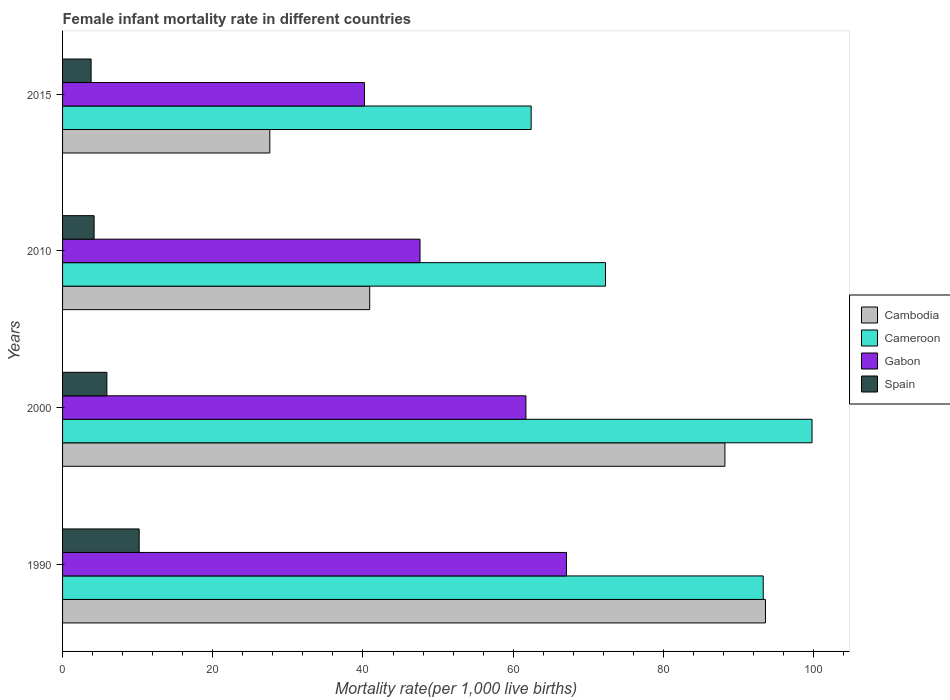How many groups of bars are there?
Your response must be concise. 4. How many bars are there on the 3rd tick from the bottom?
Offer a terse response. 4. What is the label of the 3rd group of bars from the top?
Your response must be concise. 2000. In how many cases, is the number of bars for a given year not equal to the number of legend labels?
Your answer should be very brief. 0. What is the female infant mortality rate in Spain in 2000?
Offer a terse response. 5.9. Across all years, what is the maximum female infant mortality rate in Cameroon?
Provide a short and direct response. 99.8. Across all years, what is the minimum female infant mortality rate in Spain?
Provide a succinct answer. 3.8. In which year was the female infant mortality rate in Cameroon maximum?
Provide a short and direct response. 2000. In which year was the female infant mortality rate in Cameroon minimum?
Offer a terse response. 2015. What is the total female infant mortality rate in Cameroon in the graph?
Give a very brief answer. 327.8. What is the difference between the female infant mortality rate in Gabon in 2000 and that in 2010?
Offer a terse response. 14.1. What is the difference between the female infant mortality rate in Gabon in 1990 and the female infant mortality rate in Cambodia in 2010?
Provide a short and direct response. 26.2. What is the average female infant mortality rate in Cameroon per year?
Your answer should be compact. 81.95. In the year 2010, what is the difference between the female infant mortality rate in Cambodia and female infant mortality rate in Cameroon?
Provide a short and direct response. -31.4. What is the ratio of the female infant mortality rate in Gabon in 1990 to that in 2015?
Offer a very short reply. 1.67. What is the difference between the highest and the second highest female infant mortality rate in Cambodia?
Make the answer very short. 5.4. In how many years, is the female infant mortality rate in Cambodia greater than the average female infant mortality rate in Cambodia taken over all years?
Ensure brevity in your answer.  2. Is the sum of the female infant mortality rate in Gabon in 2010 and 2015 greater than the maximum female infant mortality rate in Cameroon across all years?
Give a very brief answer. No. What does the 4th bar from the top in 2015 represents?
Your answer should be compact. Cambodia. What does the 2nd bar from the bottom in 2000 represents?
Keep it short and to the point. Cameroon. Are all the bars in the graph horizontal?
Give a very brief answer. Yes. How many years are there in the graph?
Offer a terse response. 4. What is the difference between two consecutive major ticks on the X-axis?
Provide a succinct answer. 20. Are the values on the major ticks of X-axis written in scientific E-notation?
Provide a succinct answer. No. Does the graph contain grids?
Your answer should be compact. No. How many legend labels are there?
Your answer should be compact. 4. How are the legend labels stacked?
Give a very brief answer. Vertical. What is the title of the graph?
Ensure brevity in your answer.  Female infant mortality rate in different countries. Does "Caribbean small states" appear as one of the legend labels in the graph?
Your response must be concise. No. What is the label or title of the X-axis?
Ensure brevity in your answer.  Mortality rate(per 1,0 live births). What is the Mortality rate(per 1,000 live births) in Cambodia in 1990?
Offer a very short reply. 93.6. What is the Mortality rate(per 1,000 live births) of Cameroon in 1990?
Provide a succinct answer. 93.3. What is the Mortality rate(per 1,000 live births) of Gabon in 1990?
Give a very brief answer. 67.1. What is the Mortality rate(per 1,000 live births) in Spain in 1990?
Provide a succinct answer. 10.2. What is the Mortality rate(per 1,000 live births) of Cambodia in 2000?
Provide a short and direct response. 88.2. What is the Mortality rate(per 1,000 live births) of Cameroon in 2000?
Keep it short and to the point. 99.8. What is the Mortality rate(per 1,000 live births) in Gabon in 2000?
Ensure brevity in your answer.  61.7. What is the Mortality rate(per 1,000 live births) in Spain in 2000?
Your answer should be compact. 5.9. What is the Mortality rate(per 1,000 live births) in Cambodia in 2010?
Provide a short and direct response. 40.9. What is the Mortality rate(per 1,000 live births) of Cameroon in 2010?
Your response must be concise. 72.3. What is the Mortality rate(per 1,000 live births) in Gabon in 2010?
Your answer should be compact. 47.6. What is the Mortality rate(per 1,000 live births) in Spain in 2010?
Make the answer very short. 4.2. What is the Mortality rate(per 1,000 live births) in Cambodia in 2015?
Provide a short and direct response. 27.6. What is the Mortality rate(per 1,000 live births) of Cameroon in 2015?
Provide a succinct answer. 62.4. What is the Mortality rate(per 1,000 live births) in Gabon in 2015?
Your answer should be very brief. 40.2. What is the Mortality rate(per 1,000 live births) in Spain in 2015?
Your answer should be very brief. 3.8. Across all years, what is the maximum Mortality rate(per 1,000 live births) in Cambodia?
Offer a very short reply. 93.6. Across all years, what is the maximum Mortality rate(per 1,000 live births) of Cameroon?
Your answer should be compact. 99.8. Across all years, what is the maximum Mortality rate(per 1,000 live births) in Gabon?
Keep it short and to the point. 67.1. Across all years, what is the minimum Mortality rate(per 1,000 live births) of Cambodia?
Make the answer very short. 27.6. Across all years, what is the minimum Mortality rate(per 1,000 live births) of Cameroon?
Provide a short and direct response. 62.4. Across all years, what is the minimum Mortality rate(per 1,000 live births) of Gabon?
Keep it short and to the point. 40.2. Across all years, what is the minimum Mortality rate(per 1,000 live births) in Spain?
Your response must be concise. 3.8. What is the total Mortality rate(per 1,000 live births) of Cambodia in the graph?
Your response must be concise. 250.3. What is the total Mortality rate(per 1,000 live births) of Cameroon in the graph?
Offer a terse response. 327.8. What is the total Mortality rate(per 1,000 live births) of Gabon in the graph?
Your response must be concise. 216.6. What is the total Mortality rate(per 1,000 live births) of Spain in the graph?
Provide a short and direct response. 24.1. What is the difference between the Mortality rate(per 1,000 live births) in Cambodia in 1990 and that in 2000?
Offer a terse response. 5.4. What is the difference between the Mortality rate(per 1,000 live births) of Gabon in 1990 and that in 2000?
Offer a terse response. 5.4. What is the difference between the Mortality rate(per 1,000 live births) of Spain in 1990 and that in 2000?
Your answer should be compact. 4.3. What is the difference between the Mortality rate(per 1,000 live births) of Cambodia in 1990 and that in 2010?
Your response must be concise. 52.7. What is the difference between the Mortality rate(per 1,000 live births) of Spain in 1990 and that in 2010?
Your response must be concise. 6. What is the difference between the Mortality rate(per 1,000 live births) in Cameroon in 1990 and that in 2015?
Keep it short and to the point. 30.9. What is the difference between the Mortality rate(per 1,000 live births) of Gabon in 1990 and that in 2015?
Make the answer very short. 26.9. What is the difference between the Mortality rate(per 1,000 live births) of Spain in 1990 and that in 2015?
Give a very brief answer. 6.4. What is the difference between the Mortality rate(per 1,000 live births) of Cambodia in 2000 and that in 2010?
Keep it short and to the point. 47.3. What is the difference between the Mortality rate(per 1,000 live births) of Cameroon in 2000 and that in 2010?
Make the answer very short. 27.5. What is the difference between the Mortality rate(per 1,000 live births) in Gabon in 2000 and that in 2010?
Make the answer very short. 14.1. What is the difference between the Mortality rate(per 1,000 live births) in Cambodia in 2000 and that in 2015?
Make the answer very short. 60.6. What is the difference between the Mortality rate(per 1,000 live births) in Cameroon in 2000 and that in 2015?
Ensure brevity in your answer.  37.4. What is the difference between the Mortality rate(per 1,000 live births) in Gabon in 2000 and that in 2015?
Your response must be concise. 21.5. What is the difference between the Mortality rate(per 1,000 live births) of Spain in 2000 and that in 2015?
Your answer should be compact. 2.1. What is the difference between the Mortality rate(per 1,000 live births) in Cambodia in 2010 and that in 2015?
Keep it short and to the point. 13.3. What is the difference between the Mortality rate(per 1,000 live births) of Gabon in 2010 and that in 2015?
Ensure brevity in your answer.  7.4. What is the difference between the Mortality rate(per 1,000 live births) in Spain in 2010 and that in 2015?
Offer a very short reply. 0.4. What is the difference between the Mortality rate(per 1,000 live births) of Cambodia in 1990 and the Mortality rate(per 1,000 live births) of Cameroon in 2000?
Provide a short and direct response. -6.2. What is the difference between the Mortality rate(per 1,000 live births) in Cambodia in 1990 and the Mortality rate(per 1,000 live births) in Gabon in 2000?
Give a very brief answer. 31.9. What is the difference between the Mortality rate(per 1,000 live births) in Cambodia in 1990 and the Mortality rate(per 1,000 live births) in Spain in 2000?
Your answer should be compact. 87.7. What is the difference between the Mortality rate(per 1,000 live births) of Cameroon in 1990 and the Mortality rate(per 1,000 live births) of Gabon in 2000?
Your answer should be compact. 31.6. What is the difference between the Mortality rate(per 1,000 live births) of Cameroon in 1990 and the Mortality rate(per 1,000 live births) of Spain in 2000?
Your response must be concise. 87.4. What is the difference between the Mortality rate(per 1,000 live births) of Gabon in 1990 and the Mortality rate(per 1,000 live births) of Spain in 2000?
Offer a very short reply. 61.2. What is the difference between the Mortality rate(per 1,000 live births) of Cambodia in 1990 and the Mortality rate(per 1,000 live births) of Cameroon in 2010?
Your response must be concise. 21.3. What is the difference between the Mortality rate(per 1,000 live births) of Cambodia in 1990 and the Mortality rate(per 1,000 live births) of Spain in 2010?
Make the answer very short. 89.4. What is the difference between the Mortality rate(per 1,000 live births) of Cameroon in 1990 and the Mortality rate(per 1,000 live births) of Gabon in 2010?
Provide a succinct answer. 45.7. What is the difference between the Mortality rate(per 1,000 live births) of Cameroon in 1990 and the Mortality rate(per 1,000 live births) of Spain in 2010?
Give a very brief answer. 89.1. What is the difference between the Mortality rate(per 1,000 live births) of Gabon in 1990 and the Mortality rate(per 1,000 live births) of Spain in 2010?
Your answer should be very brief. 62.9. What is the difference between the Mortality rate(per 1,000 live births) of Cambodia in 1990 and the Mortality rate(per 1,000 live births) of Cameroon in 2015?
Make the answer very short. 31.2. What is the difference between the Mortality rate(per 1,000 live births) of Cambodia in 1990 and the Mortality rate(per 1,000 live births) of Gabon in 2015?
Provide a succinct answer. 53.4. What is the difference between the Mortality rate(per 1,000 live births) in Cambodia in 1990 and the Mortality rate(per 1,000 live births) in Spain in 2015?
Provide a short and direct response. 89.8. What is the difference between the Mortality rate(per 1,000 live births) of Cameroon in 1990 and the Mortality rate(per 1,000 live births) of Gabon in 2015?
Ensure brevity in your answer.  53.1. What is the difference between the Mortality rate(per 1,000 live births) of Cameroon in 1990 and the Mortality rate(per 1,000 live births) of Spain in 2015?
Your response must be concise. 89.5. What is the difference between the Mortality rate(per 1,000 live births) of Gabon in 1990 and the Mortality rate(per 1,000 live births) of Spain in 2015?
Provide a short and direct response. 63.3. What is the difference between the Mortality rate(per 1,000 live births) in Cambodia in 2000 and the Mortality rate(per 1,000 live births) in Cameroon in 2010?
Provide a succinct answer. 15.9. What is the difference between the Mortality rate(per 1,000 live births) of Cambodia in 2000 and the Mortality rate(per 1,000 live births) of Gabon in 2010?
Provide a short and direct response. 40.6. What is the difference between the Mortality rate(per 1,000 live births) of Cambodia in 2000 and the Mortality rate(per 1,000 live births) of Spain in 2010?
Give a very brief answer. 84. What is the difference between the Mortality rate(per 1,000 live births) in Cameroon in 2000 and the Mortality rate(per 1,000 live births) in Gabon in 2010?
Offer a terse response. 52.2. What is the difference between the Mortality rate(per 1,000 live births) in Cameroon in 2000 and the Mortality rate(per 1,000 live births) in Spain in 2010?
Offer a terse response. 95.6. What is the difference between the Mortality rate(per 1,000 live births) of Gabon in 2000 and the Mortality rate(per 1,000 live births) of Spain in 2010?
Keep it short and to the point. 57.5. What is the difference between the Mortality rate(per 1,000 live births) in Cambodia in 2000 and the Mortality rate(per 1,000 live births) in Cameroon in 2015?
Keep it short and to the point. 25.8. What is the difference between the Mortality rate(per 1,000 live births) of Cambodia in 2000 and the Mortality rate(per 1,000 live births) of Gabon in 2015?
Offer a very short reply. 48. What is the difference between the Mortality rate(per 1,000 live births) in Cambodia in 2000 and the Mortality rate(per 1,000 live births) in Spain in 2015?
Provide a short and direct response. 84.4. What is the difference between the Mortality rate(per 1,000 live births) in Cameroon in 2000 and the Mortality rate(per 1,000 live births) in Gabon in 2015?
Provide a short and direct response. 59.6. What is the difference between the Mortality rate(per 1,000 live births) of Cameroon in 2000 and the Mortality rate(per 1,000 live births) of Spain in 2015?
Ensure brevity in your answer.  96. What is the difference between the Mortality rate(per 1,000 live births) in Gabon in 2000 and the Mortality rate(per 1,000 live births) in Spain in 2015?
Provide a succinct answer. 57.9. What is the difference between the Mortality rate(per 1,000 live births) in Cambodia in 2010 and the Mortality rate(per 1,000 live births) in Cameroon in 2015?
Provide a succinct answer. -21.5. What is the difference between the Mortality rate(per 1,000 live births) of Cambodia in 2010 and the Mortality rate(per 1,000 live births) of Spain in 2015?
Provide a short and direct response. 37.1. What is the difference between the Mortality rate(per 1,000 live births) in Cameroon in 2010 and the Mortality rate(per 1,000 live births) in Gabon in 2015?
Your response must be concise. 32.1. What is the difference between the Mortality rate(per 1,000 live births) of Cameroon in 2010 and the Mortality rate(per 1,000 live births) of Spain in 2015?
Your answer should be very brief. 68.5. What is the difference between the Mortality rate(per 1,000 live births) of Gabon in 2010 and the Mortality rate(per 1,000 live births) of Spain in 2015?
Provide a succinct answer. 43.8. What is the average Mortality rate(per 1,000 live births) in Cambodia per year?
Your answer should be compact. 62.58. What is the average Mortality rate(per 1,000 live births) of Cameroon per year?
Give a very brief answer. 81.95. What is the average Mortality rate(per 1,000 live births) in Gabon per year?
Ensure brevity in your answer.  54.15. What is the average Mortality rate(per 1,000 live births) of Spain per year?
Ensure brevity in your answer.  6.03. In the year 1990, what is the difference between the Mortality rate(per 1,000 live births) in Cambodia and Mortality rate(per 1,000 live births) in Cameroon?
Keep it short and to the point. 0.3. In the year 1990, what is the difference between the Mortality rate(per 1,000 live births) of Cambodia and Mortality rate(per 1,000 live births) of Spain?
Provide a short and direct response. 83.4. In the year 1990, what is the difference between the Mortality rate(per 1,000 live births) of Cameroon and Mortality rate(per 1,000 live births) of Gabon?
Provide a short and direct response. 26.2. In the year 1990, what is the difference between the Mortality rate(per 1,000 live births) of Cameroon and Mortality rate(per 1,000 live births) of Spain?
Your answer should be compact. 83.1. In the year 1990, what is the difference between the Mortality rate(per 1,000 live births) of Gabon and Mortality rate(per 1,000 live births) of Spain?
Your response must be concise. 56.9. In the year 2000, what is the difference between the Mortality rate(per 1,000 live births) of Cambodia and Mortality rate(per 1,000 live births) of Spain?
Provide a succinct answer. 82.3. In the year 2000, what is the difference between the Mortality rate(per 1,000 live births) of Cameroon and Mortality rate(per 1,000 live births) of Gabon?
Make the answer very short. 38.1. In the year 2000, what is the difference between the Mortality rate(per 1,000 live births) of Cameroon and Mortality rate(per 1,000 live births) of Spain?
Make the answer very short. 93.9. In the year 2000, what is the difference between the Mortality rate(per 1,000 live births) in Gabon and Mortality rate(per 1,000 live births) in Spain?
Give a very brief answer. 55.8. In the year 2010, what is the difference between the Mortality rate(per 1,000 live births) in Cambodia and Mortality rate(per 1,000 live births) in Cameroon?
Ensure brevity in your answer.  -31.4. In the year 2010, what is the difference between the Mortality rate(per 1,000 live births) of Cambodia and Mortality rate(per 1,000 live births) of Spain?
Give a very brief answer. 36.7. In the year 2010, what is the difference between the Mortality rate(per 1,000 live births) in Cameroon and Mortality rate(per 1,000 live births) in Gabon?
Offer a terse response. 24.7. In the year 2010, what is the difference between the Mortality rate(per 1,000 live births) of Cameroon and Mortality rate(per 1,000 live births) of Spain?
Offer a terse response. 68.1. In the year 2010, what is the difference between the Mortality rate(per 1,000 live births) in Gabon and Mortality rate(per 1,000 live births) in Spain?
Your response must be concise. 43.4. In the year 2015, what is the difference between the Mortality rate(per 1,000 live births) of Cambodia and Mortality rate(per 1,000 live births) of Cameroon?
Your answer should be compact. -34.8. In the year 2015, what is the difference between the Mortality rate(per 1,000 live births) in Cambodia and Mortality rate(per 1,000 live births) in Spain?
Your response must be concise. 23.8. In the year 2015, what is the difference between the Mortality rate(per 1,000 live births) of Cameroon and Mortality rate(per 1,000 live births) of Gabon?
Keep it short and to the point. 22.2. In the year 2015, what is the difference between the Mortality rate(per 1,000 live births) in Cameroon and Mortality rate(per 1,000 live births) in Spain?
Your answer should be compact. 58.6. In the year 2015, what is the difference between the Mortality rate(per 1,000 live births) of Gabon and Mortality rate(per 1,000 live births) of Spain?
Give a very brief answer. 36.4. What is the ratio of the Mortality rate(per 1,000 live births) in Cambodia in 1990 to that in 2000?
Offer a very short reply. 1.06. What is the ratio of the Mortality rate(per 1,000 live births) in Cameroon in 1990 to that in 2000?
Your response must be concise. 0.93. What is the ratio of the Mortality rate(per 1,000 live births) in Gabon in 1990 to that in 2000?
Give a very brief answer. 1.09. What is the ratio of the Mortality rate(per 1,000 live births) of Spain in 1990 to that in 2000?
Your response must be concise. 1.73. What is the ratio of the Mortality rate(per 1,000 live births) of Cambodia in 1990 to that in 2010?
Offer a very short reply. 2.29. What is the ratio of the Mortality rate(per 1,000 live births) in Cameroon in 1990 to that in 2010?
Give a very brief answer. 1.29. What is the ratio of the Mortality rate(per 1,000 live births) in Gabon in 1990 to that in 2010?
Offer a very short reply. 1.41. What is the ratio of the Mortality rate(per 1,000 live births) in Spain in 1990 to that in 2010?
Offer a terse response. 2.43. What is the ratio of the Mortality rate(per 1,000 live births) in Cambodia in 1990 to that in 2015?
Your answer should be compact. 3.39. What is the ratio of the Mortality rate(per 1,000 live births) of Cameroon in 1990 to that in 2015?
Make the answer very short. 1.5. What is the ratio of the Mortality rate(per 1,000 live births) in Gabon in 1990 to that in 2015?
Your answer should be compact. 1.67. What is the ratio of the Mortality rate(per 1,000 live births) in Spain in 1990 to that in 2015?
Provide a short and direct response. 2.68. What is the ratio of the Mortality rate(per 1,000 live births) in Cambodia in 2000 to that in 2010?
Offer a very short reply. 2.16. What is the ratio of the Mortality rate(per 1,000 live births) of Cameroon in 2000 to that in 2010?
Offer a terse response. 1.38. What is the ratio of the Mortality rate(per 1,000 live births) in Gabon in 2000 to that in 2010?
Your answer should be very brief. 1.3. What is the ratio of the Mortality rate(per 1,000 live births) in Spain in 2000 to that in 2010?
Make the answer very short. 1.4. What is the ratio of the Mortality rate(per 1,000 live births) of Cambodia in 2000 to that in 2015?
Your response must be concise. 3.2. What is the ratio of the Mortality rate(per 1,000 live births) of Cameroon in 2000 to that in 2015?
Keep it short and to the point. 1.6. What is the ratio of the Mortality rate(per 1,000 live births) in Gabon in 2000 to that in 2015?
Your response must be concise. 1.53. What is the ratio of the Mortality rate(per 1,000 live births) in Spain in 2000 to that in 2015?
Provide a short and direct response. 1.55. What is the ratio of the Mortality rate(per 1,000 live births) of Cambodia in 2010 to that in 2015?
Offer a very short reply. 1.48. What is the ratio of the Mortality rate(per 1,000 live births) in Cameroon in 2010 to that in 2015?
Your answer should be very brief. 1.16. What is the ratio of the Mortality rate(per 1,000 live births) of Gabon in 2010 to that in 2015?
Give a very brief answer. 1.18. What is the ratio of the Mortality rate(per 1,000 live births) of Spain in 2010 to that in 2015?
Provide a succinct answer. 1.11. What is the difference between the highest and the second highest Mortality rate(per 1,000 live births) of Gabon?
Offer a very short reply. 5.4. What is the difference between the highest and the lowest Mortality rate(per 1,000 live births) of Cameroon?
Keep it short and to the point. 37.4. What is the difference between the highest and the lowest Mortality rate(per 1,000 live births) in Gabon?
Offer a terse response. 26.9. What is the difference between the highest and the lowest Mortality rate(per 1,000 live births) in Spain?
Ensure brevity in your answer.  6.4. 